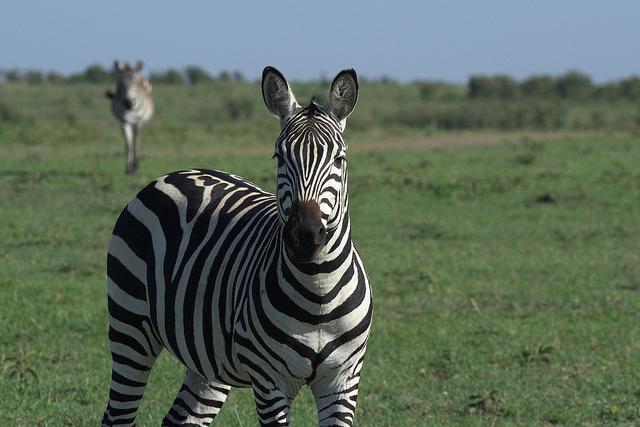How many animals are in the background?
Give a very brief answer. 1. How many zebras can you see?
Give a very brief answer. 2. How many cakes are pictured?
Give a very brief answer. 0. 